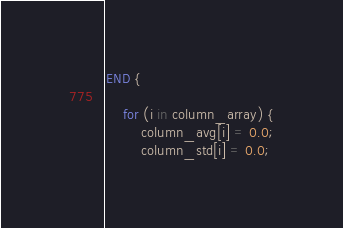<code> <loc_0><loc_0><loc_500><loc_500><_Awk_>END {
	
	for (i in column_array) {
		column_avg[i] = 0.0;
		column_std[i] = 0.0;</code> 